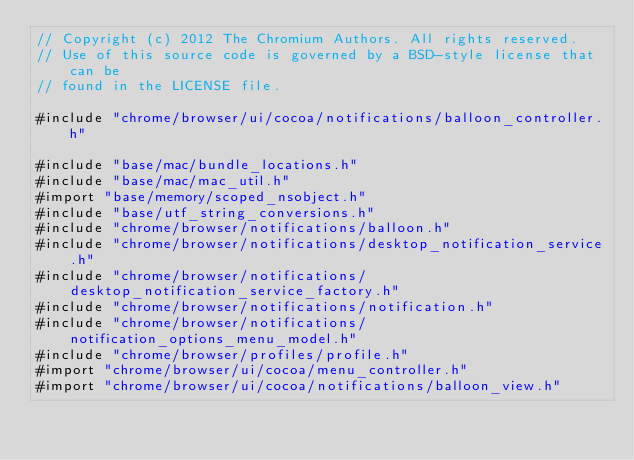Convert code to text. <code><loc_0><loc_0><loc_500><loc_500><_ObjectiveC_>// Copyright (c) 2012 The Chromium Authors. All rights reserved.
// Use of this source code is governed by a BSD-style license that can be
// found in the LICENSE file.

#include "chrome/browser/ui/cocoa/notifications/balloon_controller.h"

#include "base/mac/bundle_locations.h"
#include "base/mac/mac_util.h"
#import "base/memory/scoped_nsobject.h"
#include "base/utf_string_conversions.h"
#include "chrome/browser/notifications/balloon.h"
#include "chrome/browser/notifications/desktop_notification_service.h"
#include "chrome/browser/notifications/desktop_notification_service_factory.h"
#include "chrome/browser/notifications/notification.h"
#include "chrome/browser/notifications/notification_options_menu_model.h"
#include "chrome/browser/profiles/profile.h"
#import "chrome/browser/ui/cocoa/menu_controller.h"
#import "chrome/browser/ui/cocoa/notifications/balloon_view.h"</code> 